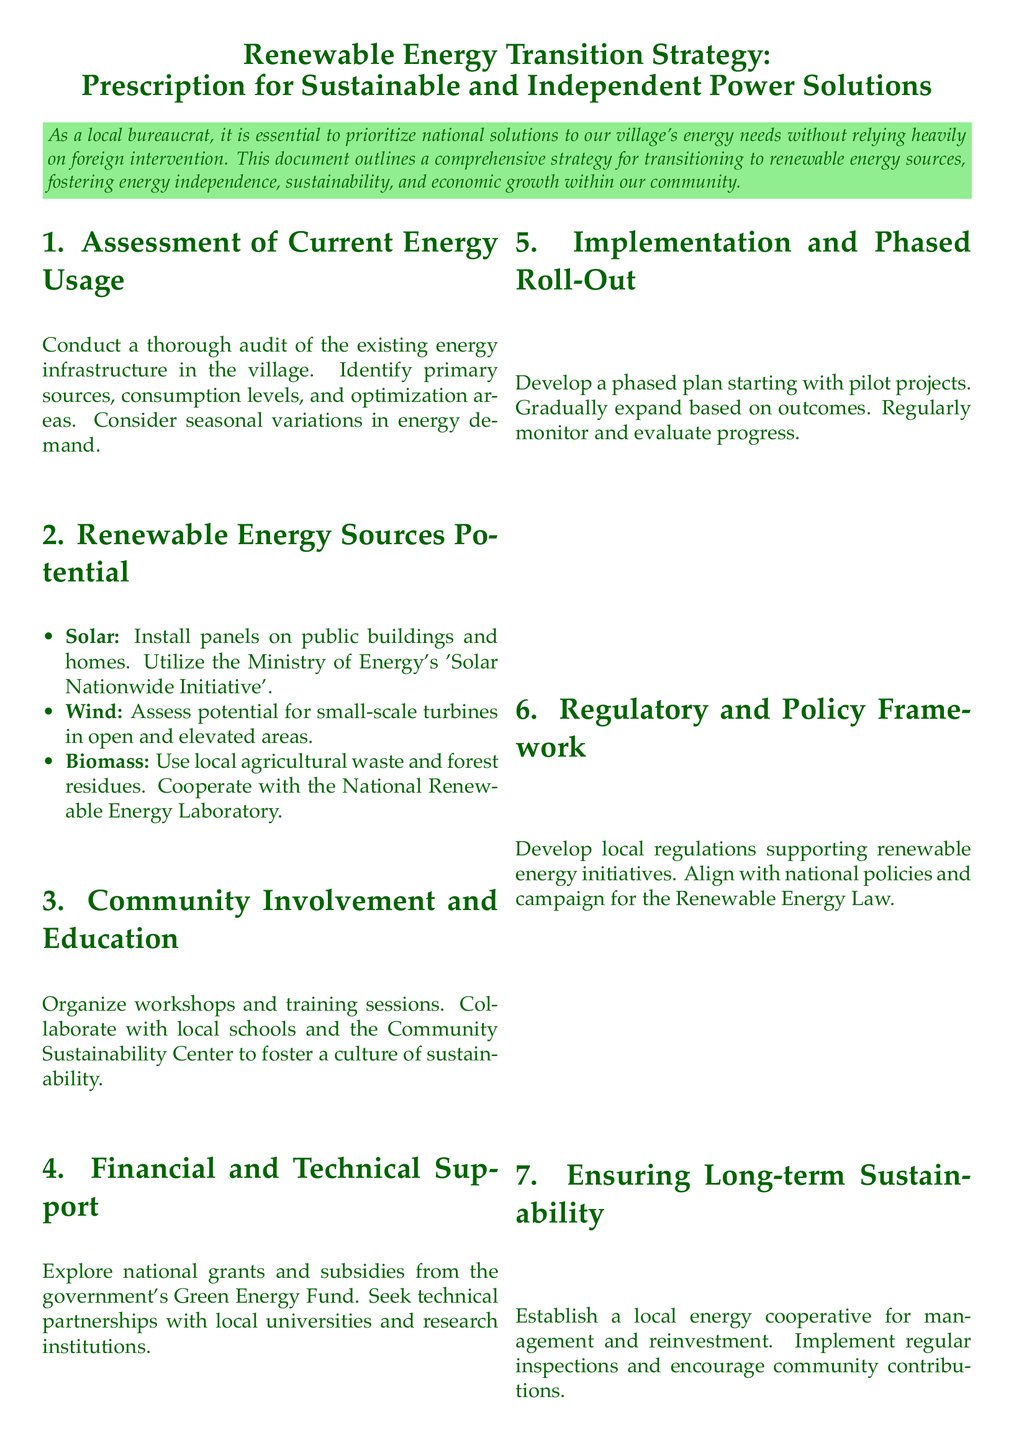What is the first step in the strategy? The first step involves conducting a thorough audit of the existing energy infrastructure in the village.
Answer: Conduct a thorough audit of the existing energy infrastructure What renewable energy source is suggested for public buildings? The document suggests installing solar panels on public buildings and homes as part of the solar initiative.
Answer: Solar panels Which local resources are proposed for biomass energy? The document mentions using local agricultural waste and forest residues for biomass energy.
Answer: Agricultural waste and forest residues What body is responsible for the Green Energy Fund? The Green Energy Fund is managed by the government as indicated in the document.
Answer: Government What is the role of the Community Sustainability Center? The center is involved in organizing workshops and training sessions to foster a culture of sustainability.
Answer: Organizing workshops What type of project is recommended for the implementation phase? The document recommends starting with pilot projects during the implementation phase.
Answer: Pilot projects How are the local regulations meant to align? Local regulations should align with national policies supporting renewable energy initiatives.
Answer: National policies What is the purpose of the local energy cooperative mentioned? The cooperative is established for management and reinvestment in energy solutions.
Answer: Management and reinvestment 